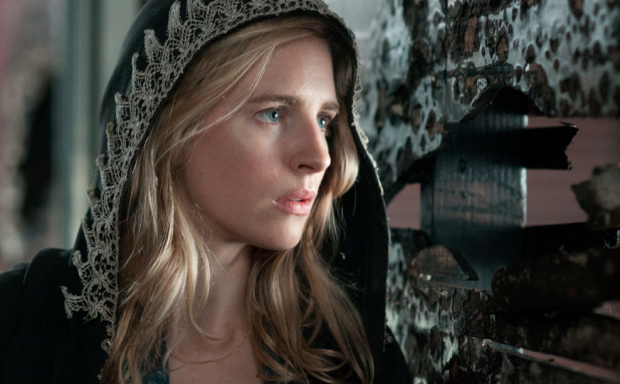If she were to step through a portal, where might she end up? If she were to step through a portal, the woman might find herself in a parallel universe filled with intricate mazes and labyrinthine passageways. This new world could be an ethereal realm where reality bends and twists, filled with echoes of forgotten memories and shadows of unresolved pasts. As she navigates this strange dimension, she might encounter beings or spirits that hold keys to the mysteries she's trying to unravel, pushing her to confront her deepest fears and discover hidden strengths. 